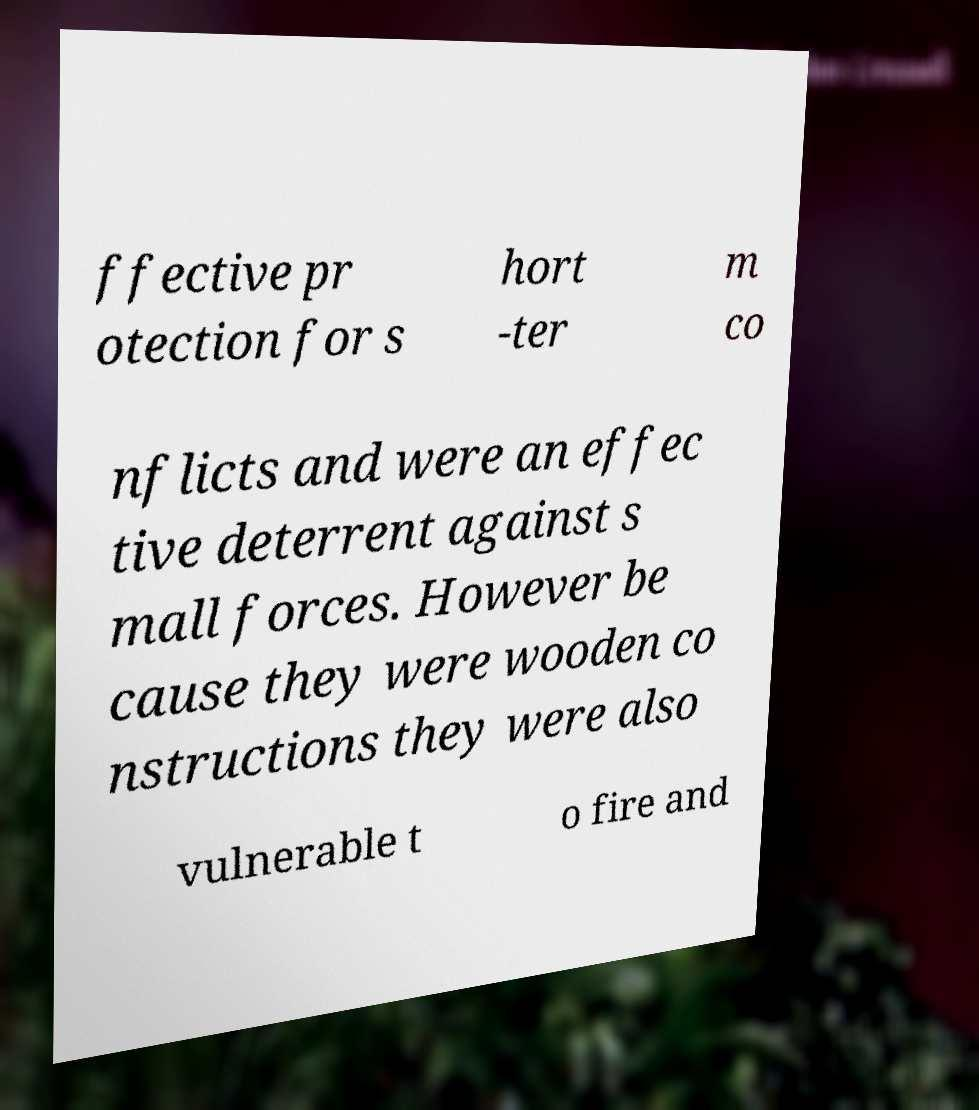Can you read and provide the text displayed in the image?This photo seems to have some interesting text. Can you extract and type it out for me? ffective pr otection for s hort -ter m co nflicts and were an effec tive deterrent against s mall forces. However be cause they were wooden co nstructions they were also vulnerable t o fire and 